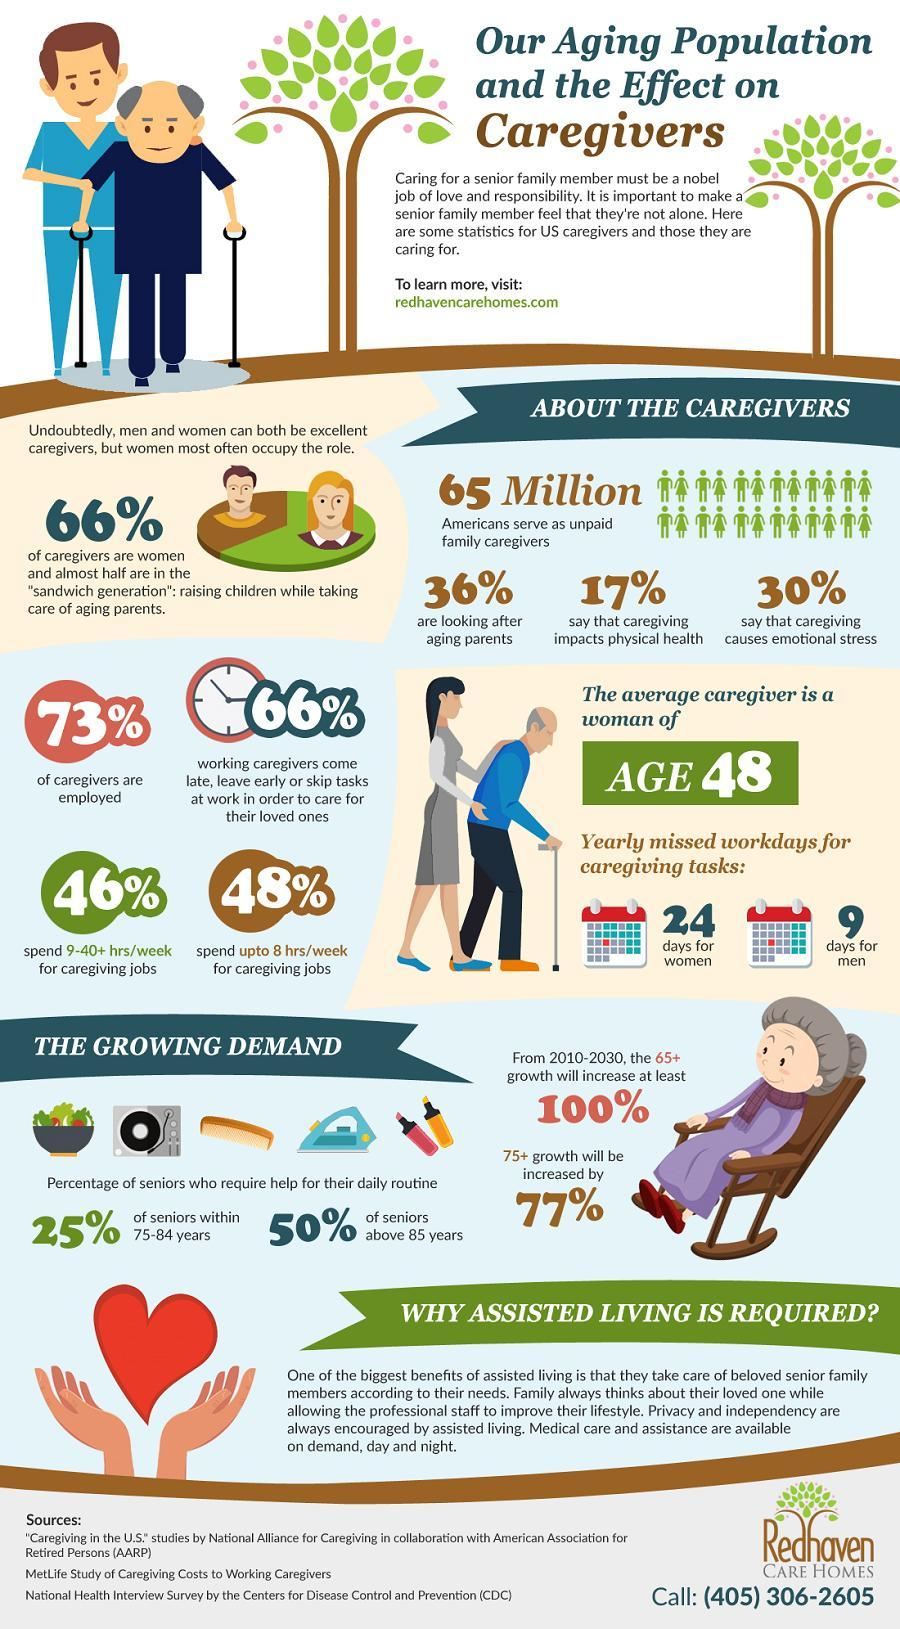What percentage of caregivers are looking after aging parents?
Answer the question with a short phrase. 36% What percentage of caregivers are not women? 34% What percentage of caregivers spend 9-40+hrs/week for caregiving jobs? 46% What percentage of caregivers are not employed? 27% 